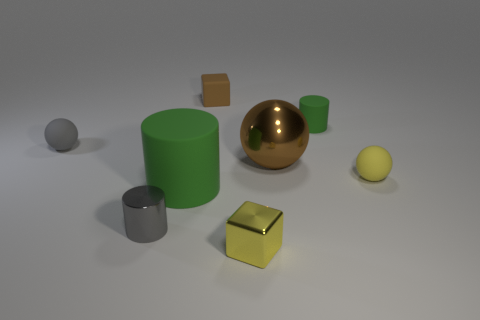Add 1 gray matte spheres. How many objects exist? 9 Subtract all brown blocks. Subtract all metallic cubes. How many objects are left? 6 Add 3 yellow cubes. How many yellow cubes are left? 4 Add 6 yellow spheres. How many yellow spheres exist? 7 Subtract 0 brown cylinders. How many objects are left? 8 Subtract all balls. How many objects are left? 5 